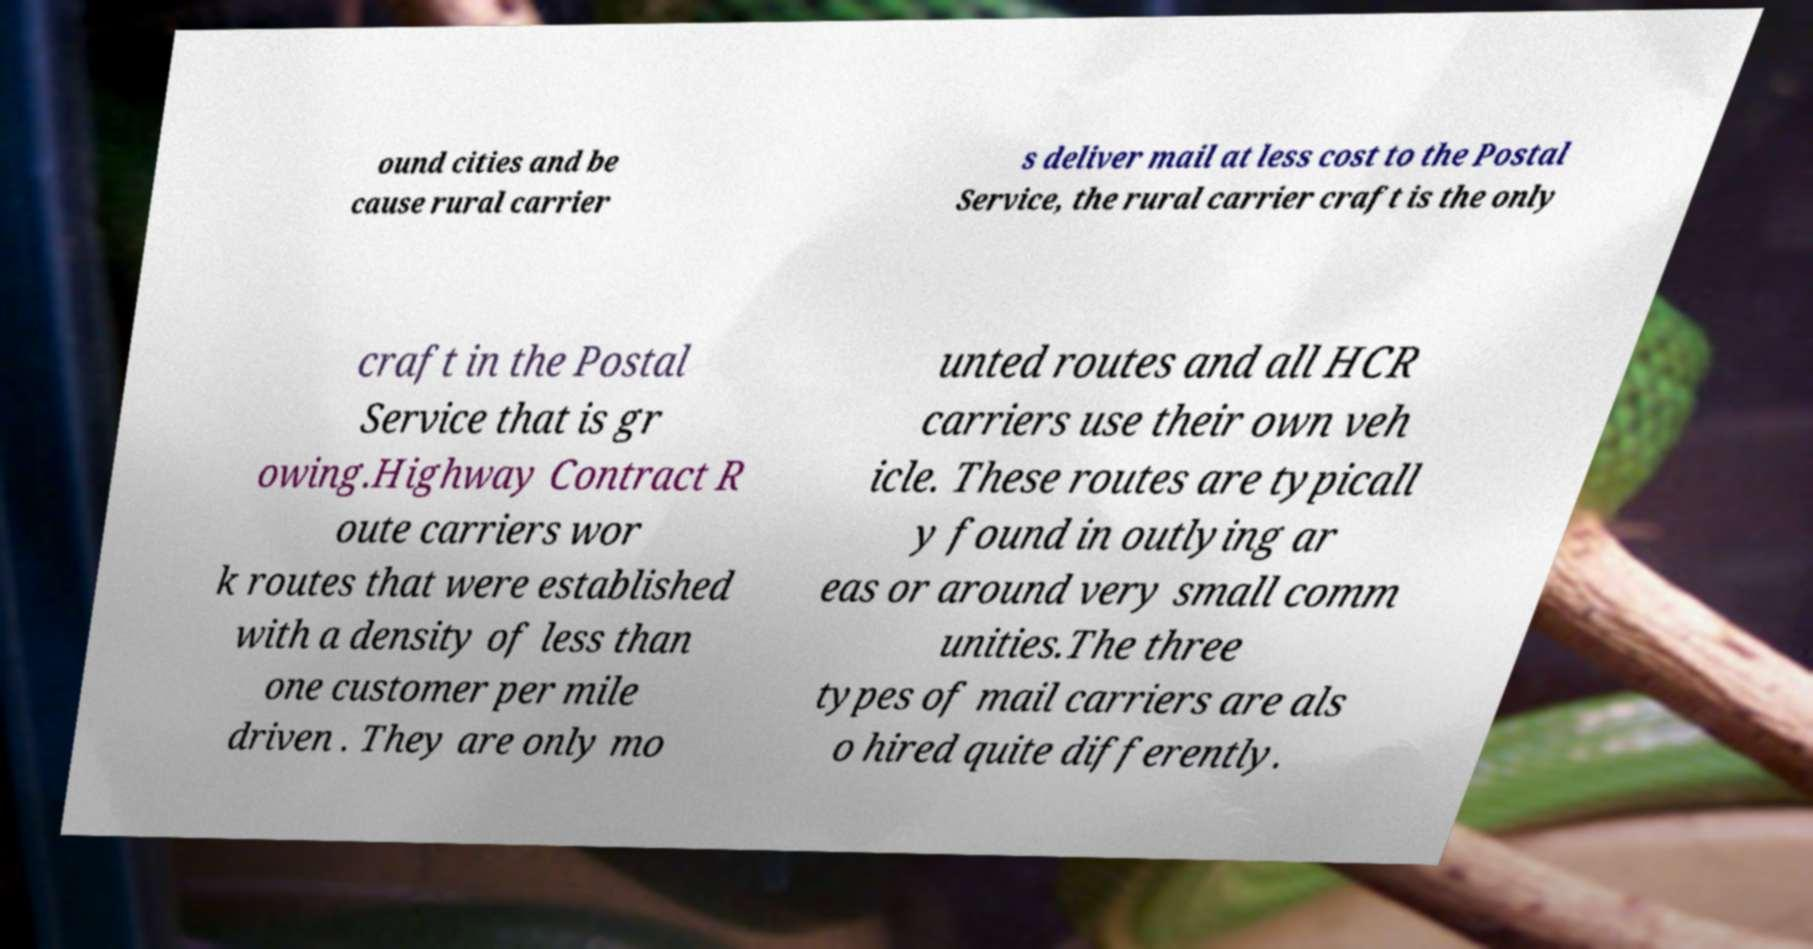Please read and relay the text visible in this image. What does it say? ound cities and be cause rural carrier s deliver mail at less cost to the Postal Service, the rural carrier craft is the only craft in the Postal Service that is gr owing.Highway Contract R oute carriers wor k routes that were established with a density of less than one customer per mile driven . They are only mo unted routes and all HCR carriers use their own veh icle. These routes are typicall y found in outlying ar eas or around very small comm unities.The three types of mail carriers are als o hired quite differently. 